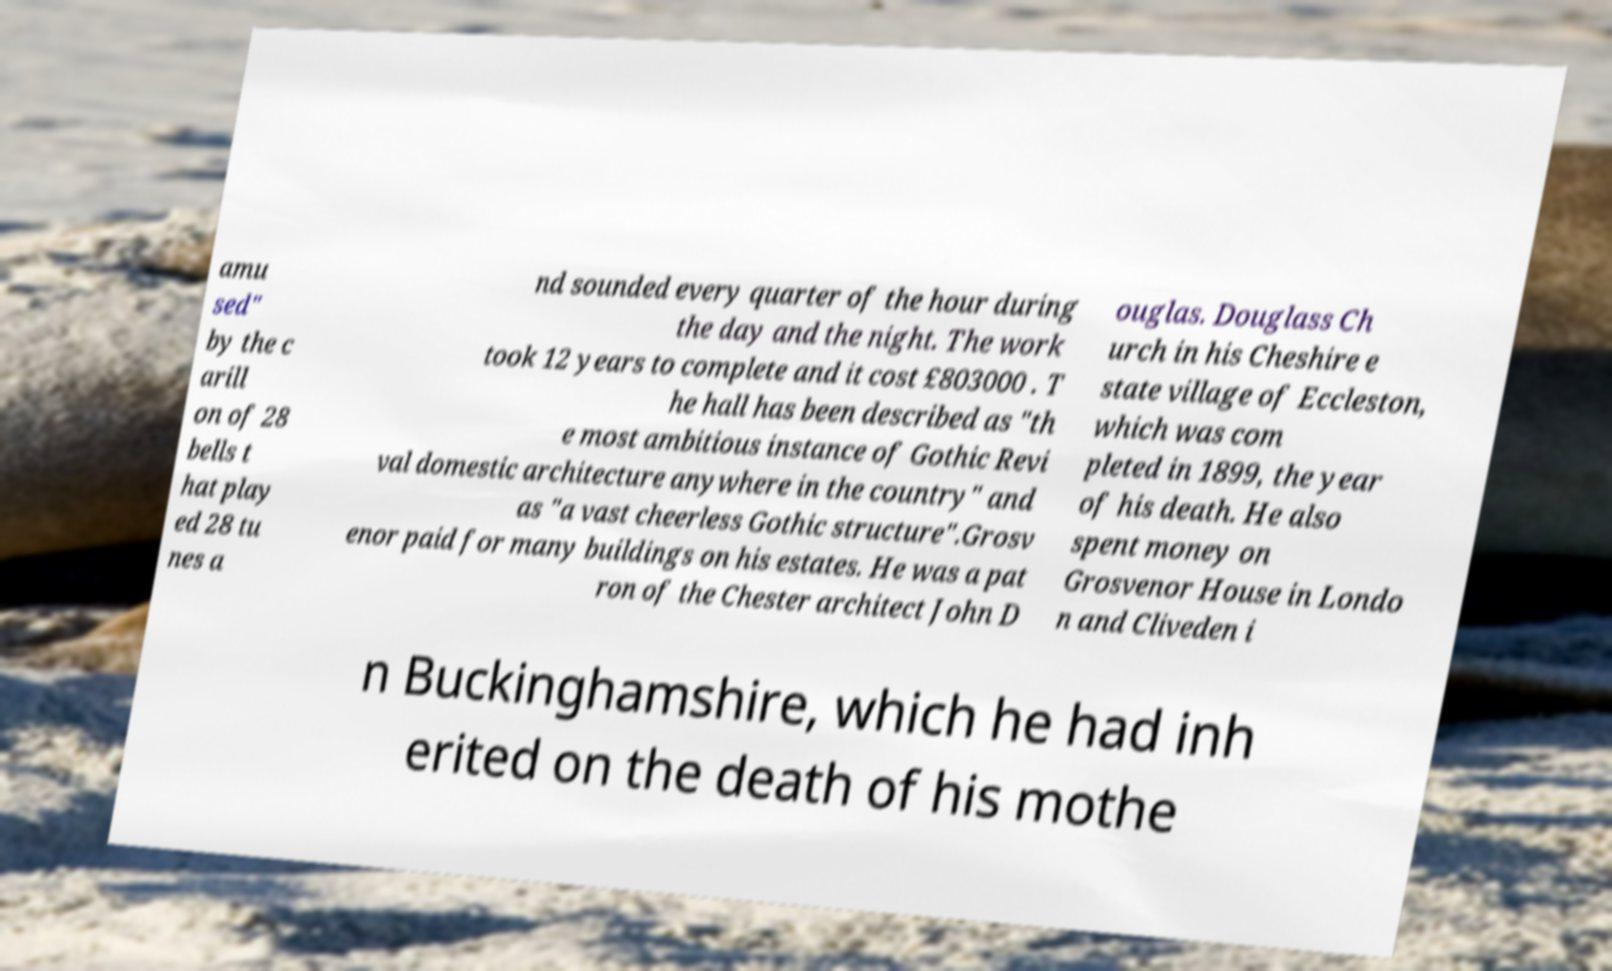I need the written content from this picture converted into text. Can you do that? amu sed" by the c arill on of 28 bells t hat play ed 28 tu nes a nd sounded every quarter of the hour during the day and the night. The work took 12 years to complete and it cost £803000 . T he hall has been described as "th e most ambitious instance of Gothic Revi val domestic architecture anywhere in the country" and as "a vast cheerless Gothic structure".Grosv enor paid for many buildings on his estates. He was a pat ron of the Chester architect John D ouglas. Douglass Ch urch in his Cheshire e state village of Eccleston, which was com pleted in 1899, the year of his death. He also spent money on Grosvenor House in Londo n and Cliveden i n Buckinghamshire, which he had inh erited on the death of his mothe 